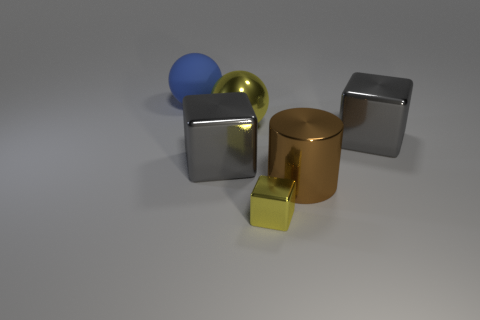Which objects in the image look like they have the smoothest surface? The gold-colored cylinder and the silver cubes appear to have the smoothest surfaces, reflecting light uniformly with minimal textural interruption. 